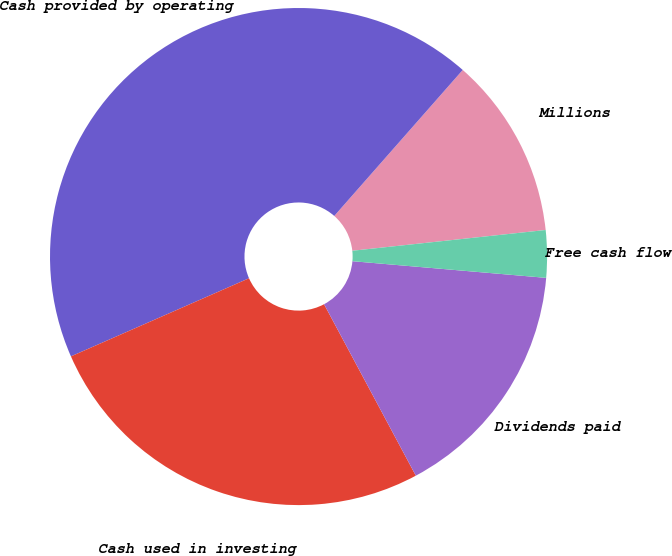Convert chart. <chart><loc_0><loc_0><loc_500><loc_500><pie_chart><fcel>Millions<fcel>Cash provided by operating<fcel>Cash used in investing<fcel>Dividends paid<fcel>Free cash flow<nl><fcel>11.81%<fcel>43.06%<fcel>26.24%<fcel>15.81%<fcel>3.07%<nl></chart> 